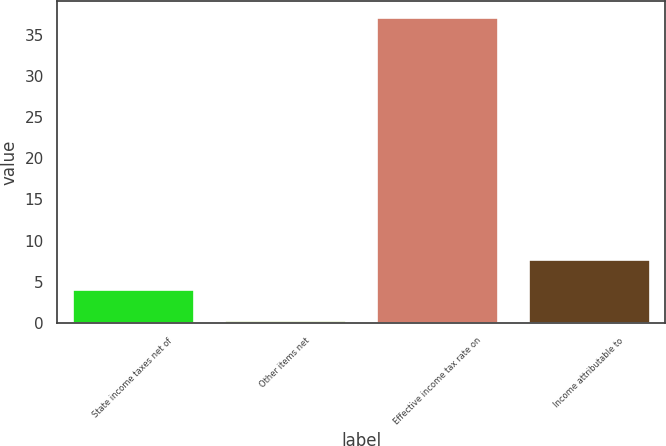Convert chart to OTSL. <chart><loc_0><loc_0><loc_500><loc_500><bar_chart><fcel>State income taxes net of<fcel>Other items net<fcel>Effective income tax rate on<fcel>Income attributable to<nl><fcel>4.08<fcel>0.4<fcel>37.2<fcel>7.76<nl></chart> 